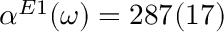<formula> <loc_0><loc_0><loc_500><loc_500>\alpha ^ { E 1 } ( \omega ) = 2 8 7 ( 1 7 )</formula> 